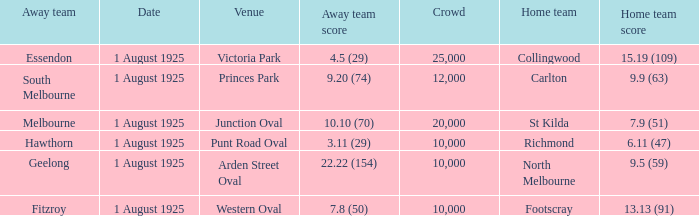Write the full table. {'header': ['Away team', 'Date', 'Venue', 'Away team score', 'Crowd', 'Home team', 'Home team score'], 'rows': [['Essendon', '1 August 1925', 'Victoria Park', '4.5 (29)', '25,000', 'Collingwood', '15.19 (109)'], ['South Melbourne', '1 August 1925', 'Princes Park', '9.20 (74)', '12,000', 'Carlton', '9.9 (63)'], ['Melbourne', '1 August 1925', 'Junction Oval', '10.10 (70)', '20,000', 'St Kilda', '7.9 (51)'], ['Hawthorn', '1 August 1925', 'Punt Road Oval', '3.11 (29)', '10,000', 'Richmond', '6.11 (47)'], ['Geelong', '1 August 1925', 'Arden Street Oval', '22.22 (154)', '10,000', 'North Melbourne', '9.5 (59)'], ['Fitzroy', '1 August 1925', 'Western Oval', '7.8 (50)', '10,000', 'Footscray', '13.13 (91)']]} When did the match take place that had a home team score of 7.9 (51)? 1 August 1925. 